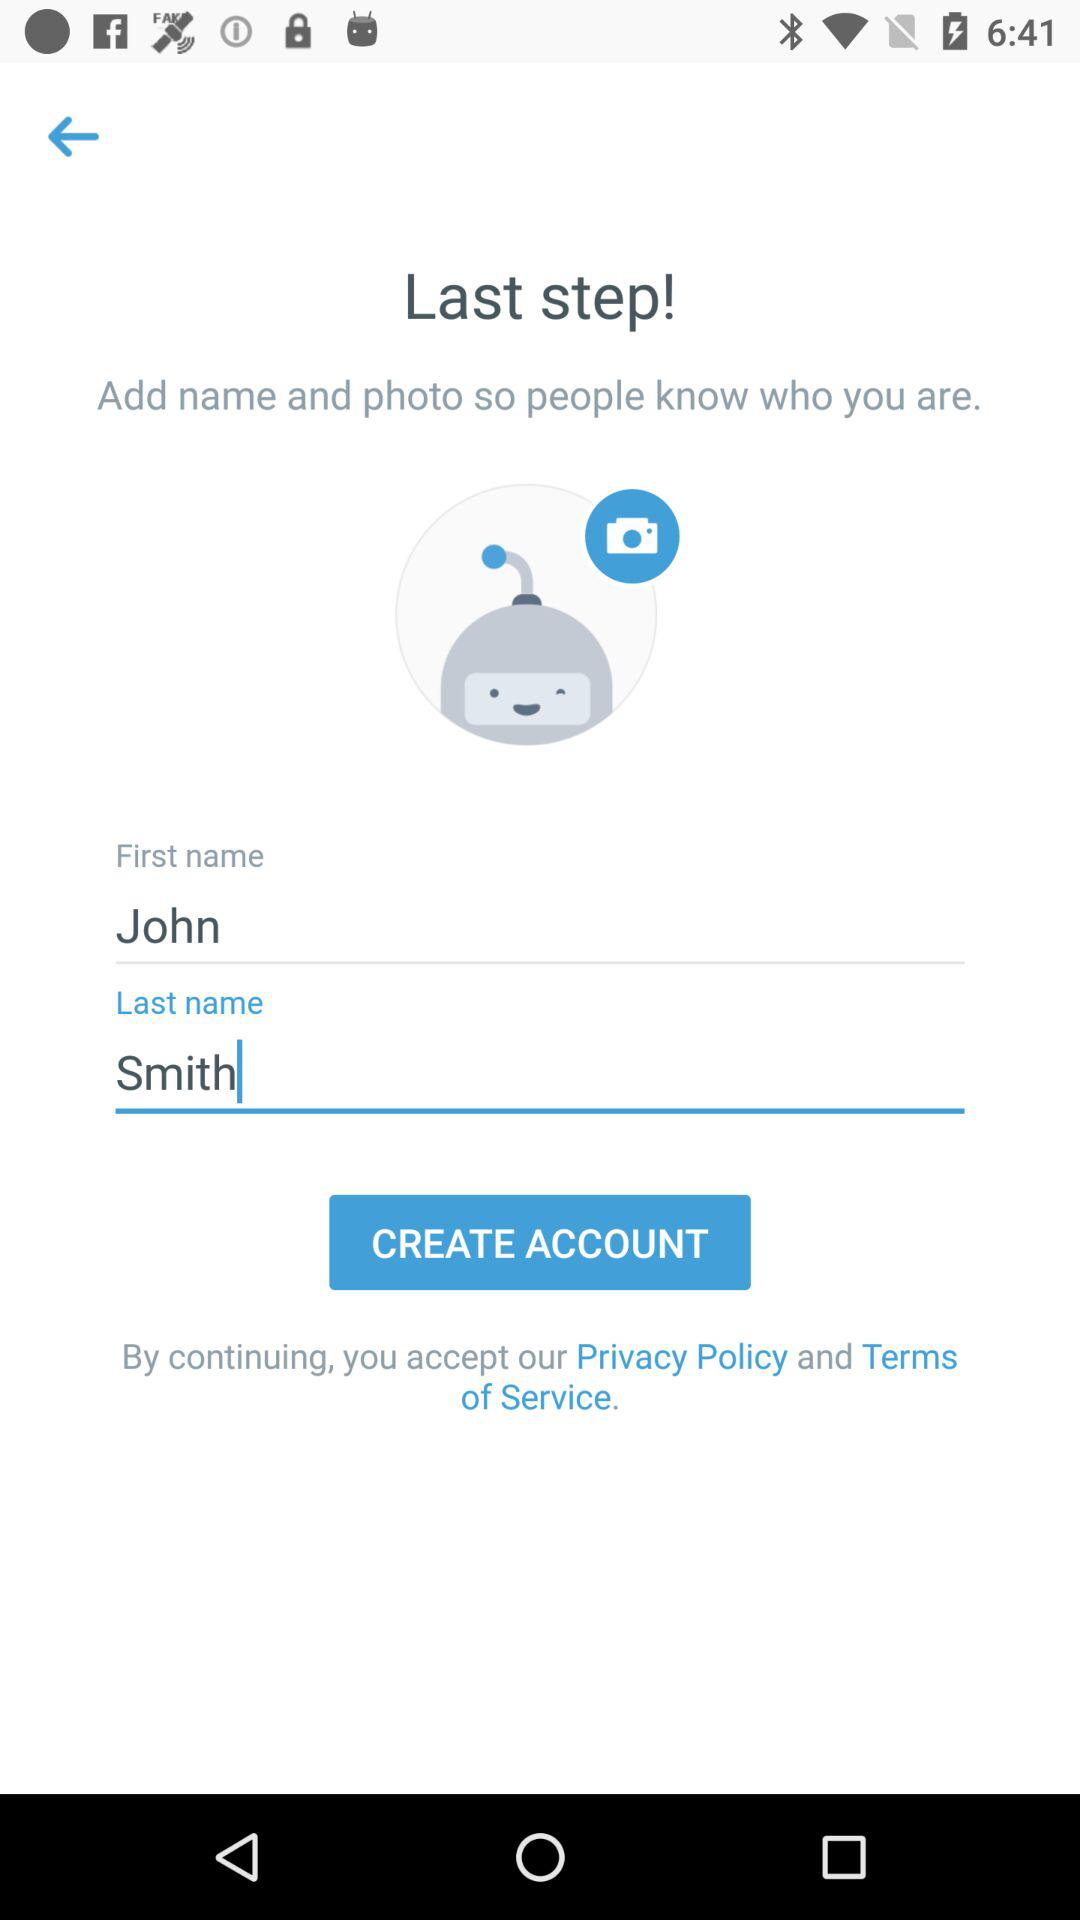What is the last name? The last name is Smith. 